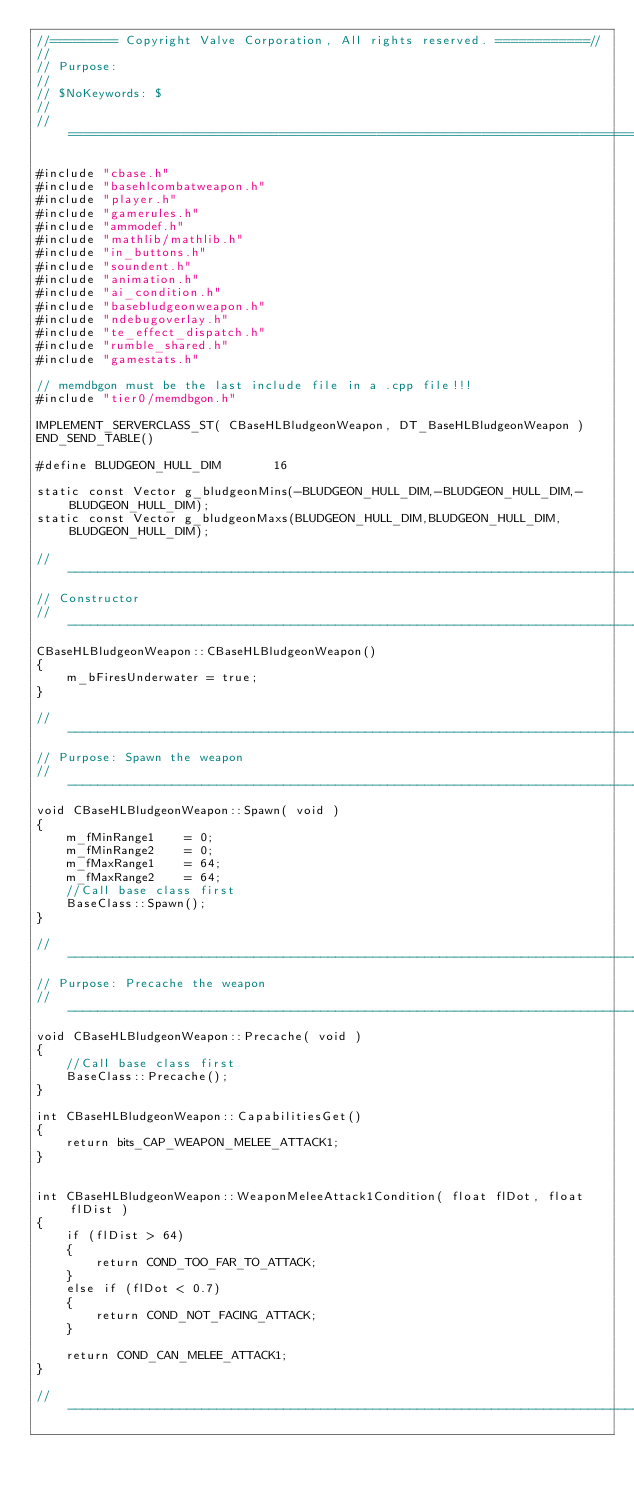Convert code to text. <code><loc_0><loc_0><loc_500><loc_500><_C++_>//========= Copyright Valve Corporation, All rights reserved. ============//
//
// Purpose: 
//
// $NoKeywords: $
//
//=============================================================================//

#include "cbase.h"
#include "basehlcombatweapon.h"
#include "player.h"
#include "gamerules.h"
#include "ammodef.h"
#include "mathlib/mathlib.h"
#include "in_buttons.h"
#include "soundent.h"
#include "animation.h"
#include "ai_condition.h"
#include "basebludgeonweapon.h"
#include "ndebugoverlay.h"
#include "te_effect_dispatch.h"
#include "rumble_shared.h"
#include "gamestats.h"

// memdbgon must be the last include file in a .cpp file!!!
#include "tier0/memdbgon.h"

IMPLEMENT_SERVERCLASS_ST( CBaseHLBludgeonWeapon, DT_BaseHLBludgeonWeapon )
END_SEND_TABLE()

#define BLUDGEON_HULL_DIM		16

static const Vector g_bludgeonMins(-BLUDGEON_HULL_DIM,-BLUDGEON_HULL_DIM,-BLUDGEON_HULL_DIM);
static const Vector g_bludgeonMaxs(BLUDGEON_HULL_DIM,BLUDGEON_HULL_DIM,BLUDGEON_HULL_DIM);

//-----------------------------------------------------------------------------
// Constructor
//-----------------------------------------------------------------------------
CBaseHLBludgeonWeapon::CBaseHLBludgeonWeapon()
{
	m_bFiresUnderwater = true;
}

//-----------------------------------------------------------------------------
// Purpose: Spawn the weapon
//-----------------------------------------------------------------------------
void CBaseHLBludgeonWeapon::Spawn( void )
{
	m_fMinRange1	= 0;
	m_fMinRange2	= 0;
	m_fMaxRange1	= 64;
	m_fMaxRange2	= 64;
	//Call base class first
	BaseClass::Spawn();
}

//-----------------------------------------------------------------------------
// Purpose: Precache the weapon
//-----------------------------------------------------------------------------
void CBaseHLBludgeonWeapon::Precache( void )
{
	//Call base class first
	BaseClass::Precache();
}

int CBaseHLBludgeonWeapon::CapabilitiesGet()
{ 
	return bits_CAP_WEAPON_MELEE_ATTACK1; 
}


int CBaseHLBludgeonWeapon::WeaponMeleeAttack1Condition( float flDot, float flDist )
{
	if (flDist > 64)
	{
		return COND_TOO_FAR_TO_ATTACK;
	}
	else if (flDot < 0.7)
	{
		return COND_NOT_FACING_ATTACK;
	}

	return COND_CAN_MELEE_ATTACK1;
}

//------------------------------------------------------------------------------</code> 